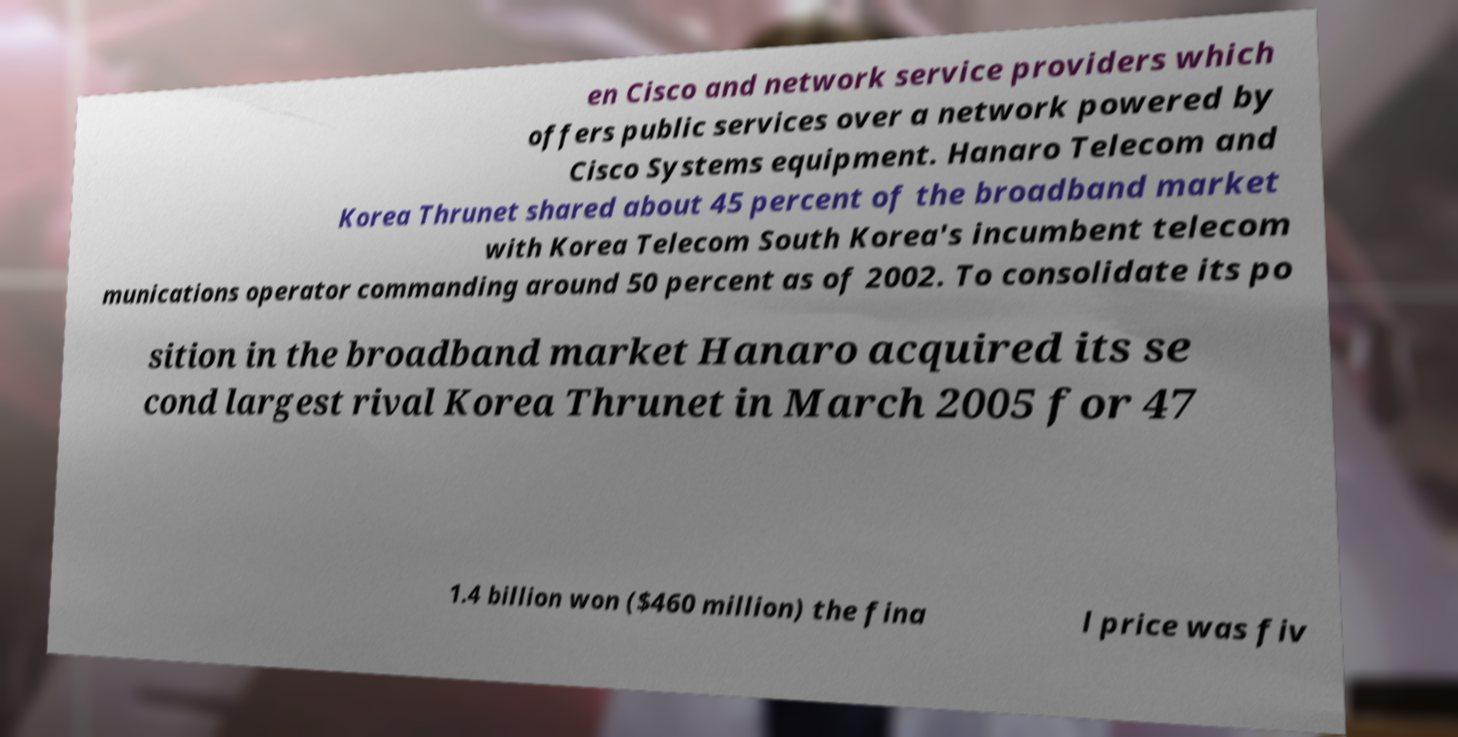Can you accurately transcribe the text from the provided image for me? en Cisco and network service providers which offers public services over a network powered by Cisco Systems equipment. Hanaro Telecom and Korea Thrunet shared about 45 percent of the broadband market with Korea Telecom South Korea's incumbent telecom munications operator commanding around 50 percent as of 2002. To consolidate its po sition in the broadband market Hanaro acquired its se cond largest rival Korea Thrunet in March 2005 for 47 1.4 billion won ($460 million) the fina l price was fiv 